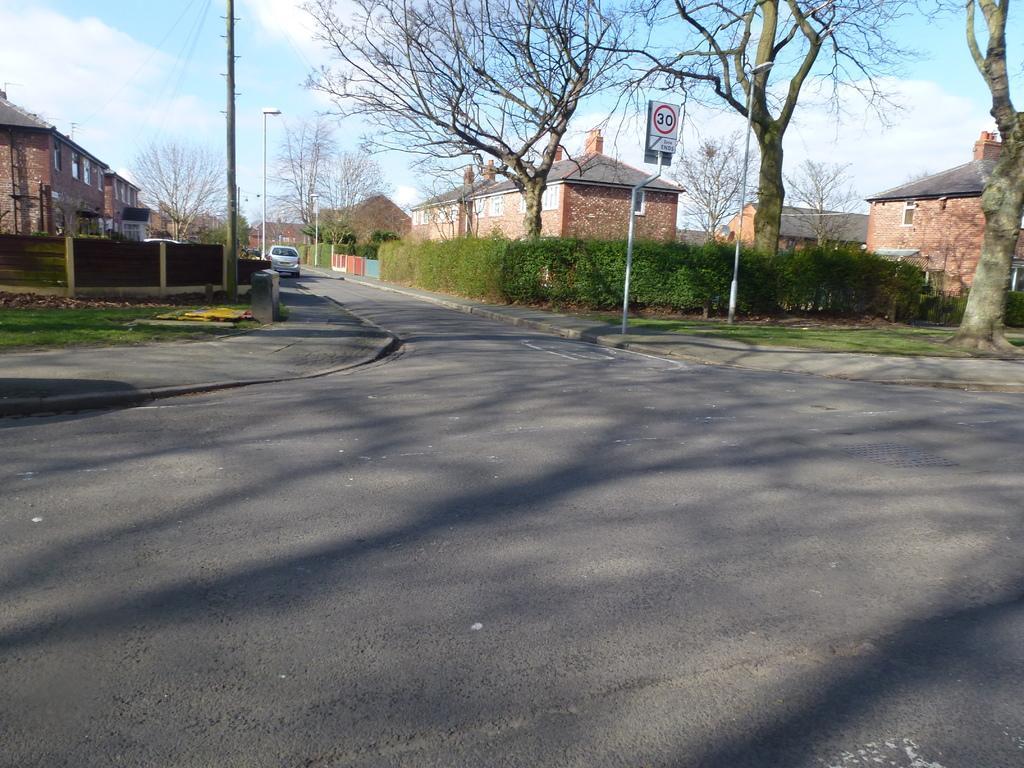In one or two sentences, can you explain what this image depicts? In this image we can see the road, vehicle, grass, plants, dried trees, fence, street lights, houses, electrical poles, some written text on the board. 